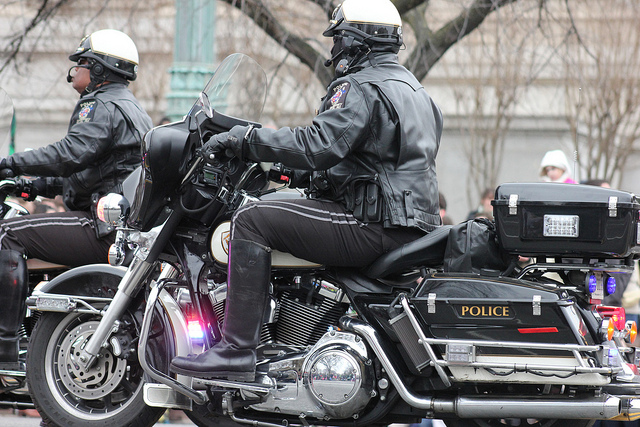Read and extract the text from this image. POLICE 